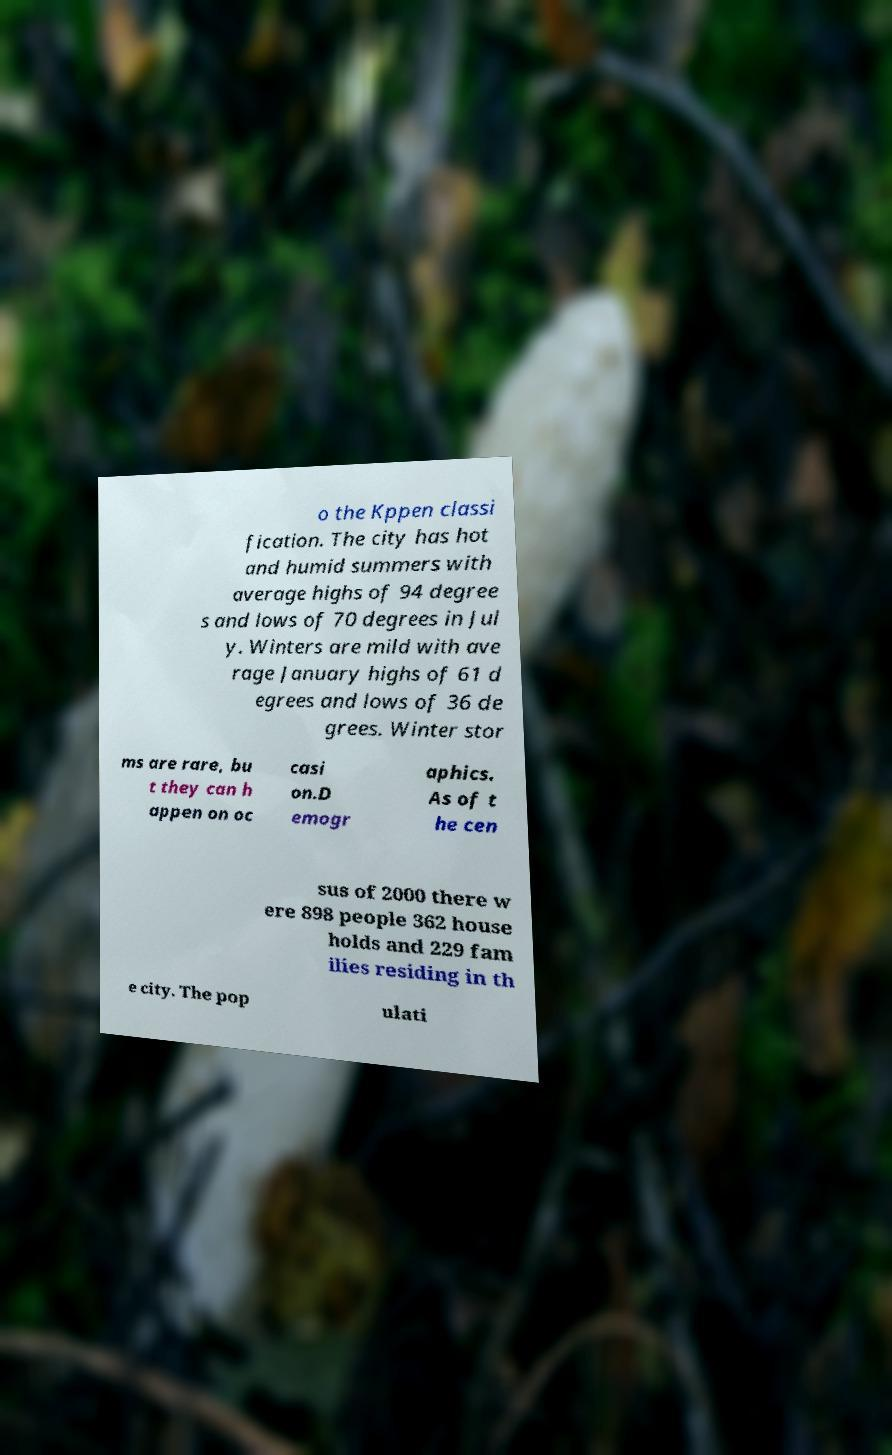Can you read and provide the text displayed in the image?This photo seems to have some interesting text. Can you extract and type it out for me? o the Kppen classi fication. The city has hot and humid summers with average highs of 94 degree s and lows of 70 degrees in Jul y. Winters are mild with ave rage January highs of 61 d egrees and lows of 36 de grees. Winter stor ms are rare, bu t they can h appen on oc casi on.D emogr aphics. As of t he cen sus of 2000 there w ere 898 people 362 house holds and 229 fam ilies residing in th e city. The pop ulati 